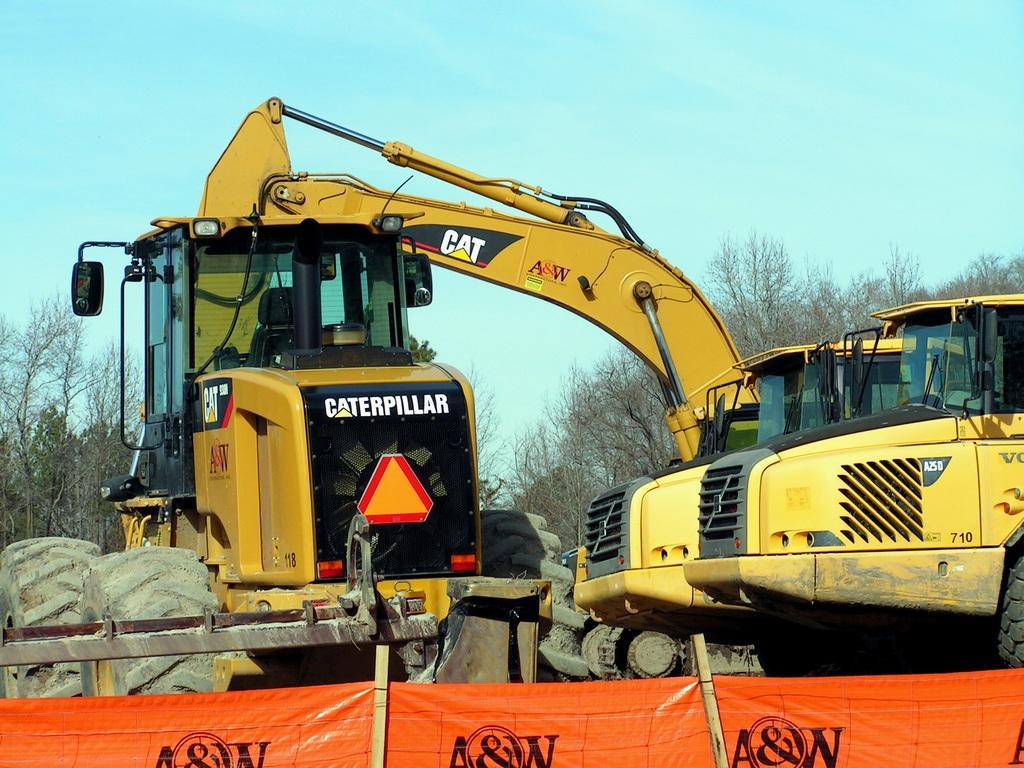Please provide a concise description of this image. In this picture there is an excavator. On the background there are many trees. And this is the sky. 